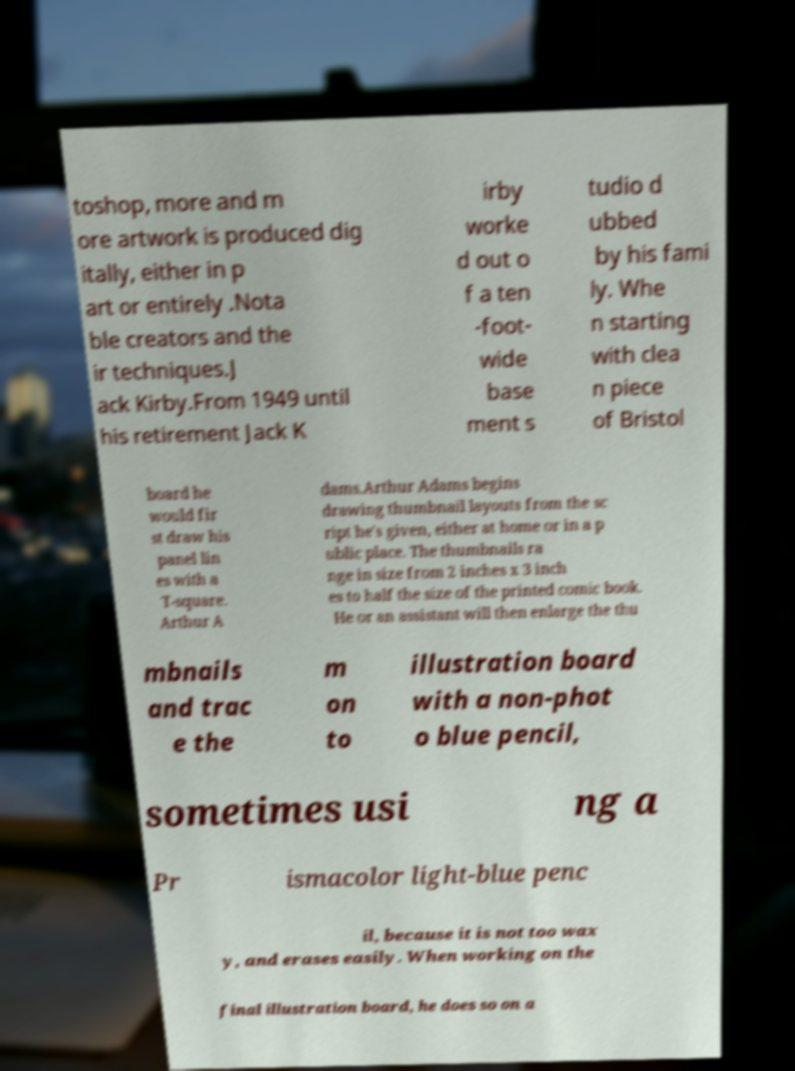Could you extract and type out the text from this image? toshop, more and m ore artwork is produced dig itally, either in p art or entirely .Nota ble creators and the ir techniques.J ack Kirby.From 1949 until his retirement Jack K irby worke d out o f a ten -foot- wide base ment s tudio d ubbed by his fami ly. Whe n starting with clea n piece of Bristol board he would fir st draw his panel lin es with a T-square. Arthur A dams.Arthur Adams begins drawing thumbnail layouts from the sc ript he's given, either at home or in a p ublic place. The thumbnails ra nge in size from 2 inches x 3 inch es to half the size of the printed comic book. He or an assistant will then enlarge the thu mbnails and trac e the m on to illustration board with a non-phot o blue pencil, sometimes usi ng a Pr ismacolor light-blue penc il, because it is not too wax y, and erases easily. When working on the final illustration board, he does so on a 